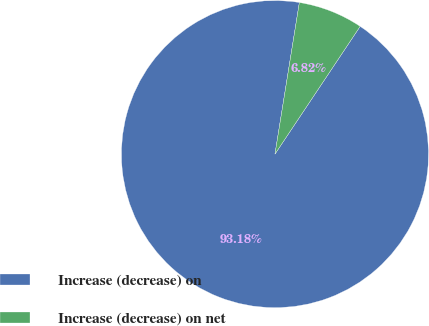<chart> <loc_0><loc_0><loc_500><loc_500><pie_chart><fcel>Increase (decrease) on<fcel>Increase (decrease) on net<nl><fcel>93.18%<fcel>6.82%<nl></chart> 